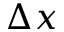<formula> <loc_0><loc_0><loc_500><loc_500>\Delta x</formula> 